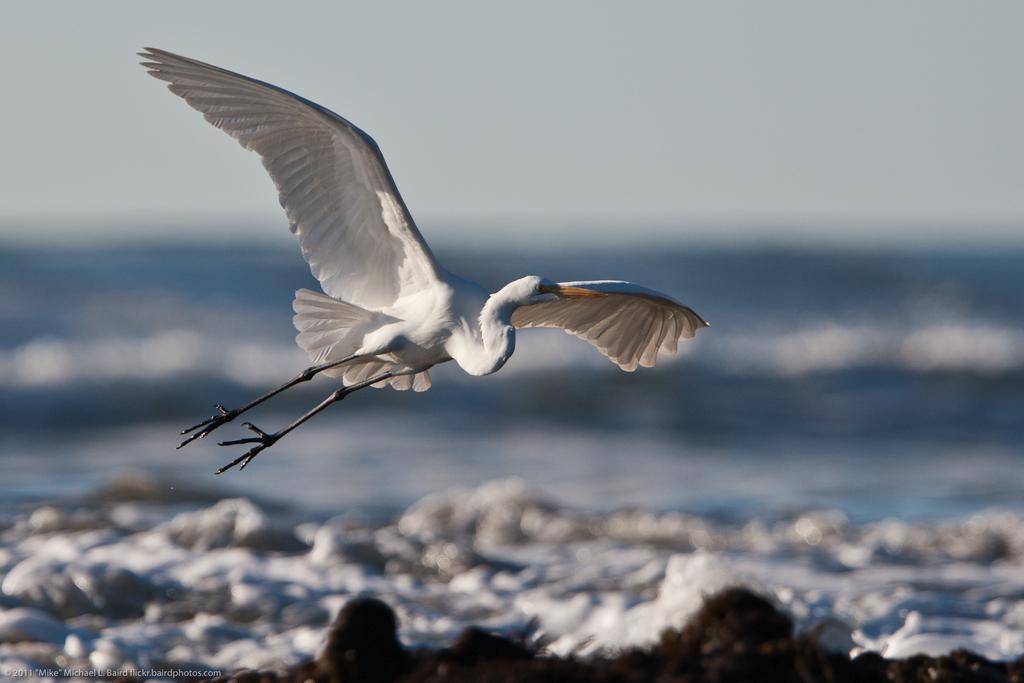Can you describe this image briefly? In this image, we can see a bird flying and at the bottom, there is water and some rocks and we can see some text. 